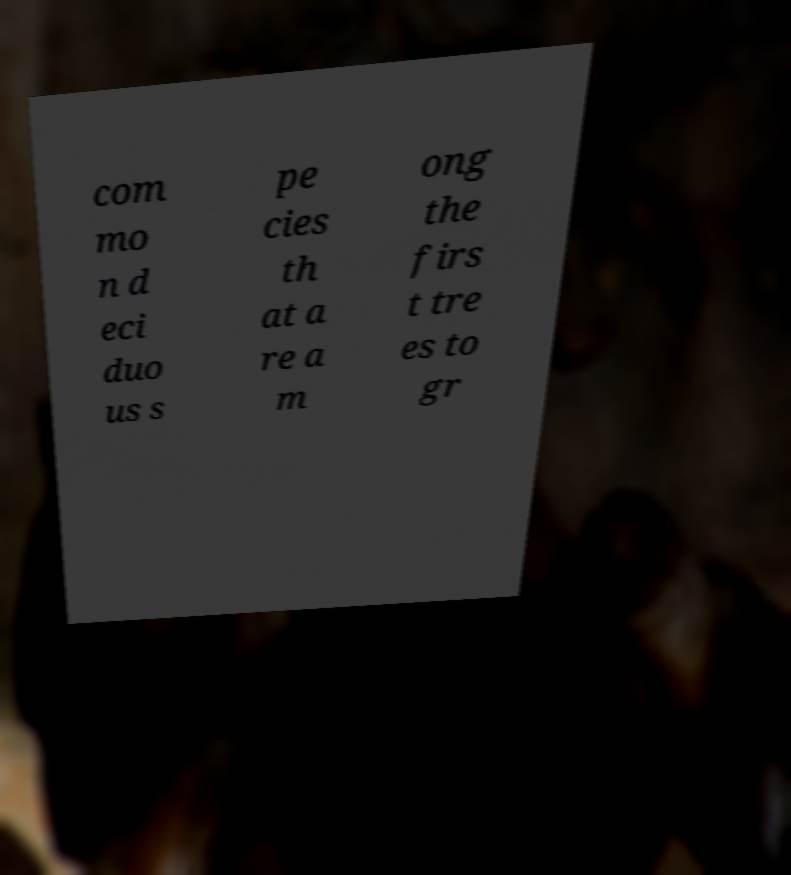Could you assist in decoding the text presented in this image and type it out clearly? com mo n d eci duo us s pe cies th at a re a m ong the firs t tre es to gr 